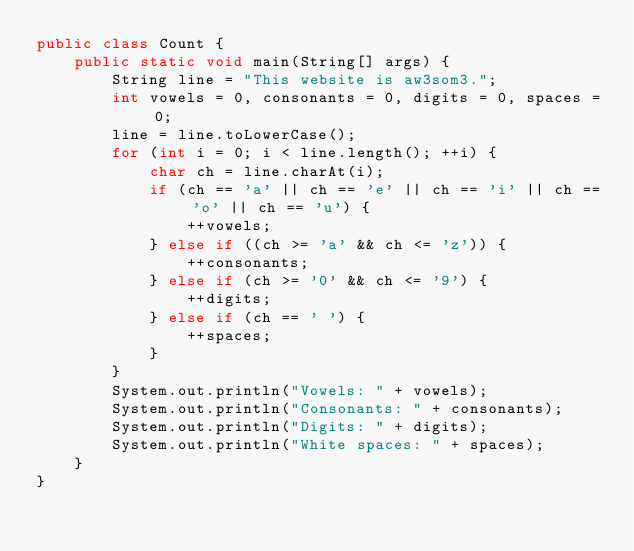Convert code to text. <code><loc_0><loc_0><loc_500><loc_500><_Java_>public class Count {
    public static void main(String[] args) {
        String line = "This website is aw3som3.";
        int vowels = 0, consonants = 0, digits = 0, spaces = 0;
        line = line.toLowerCase();
        for (int i = 0; i < line.length(); ++i) {
            char ch = line.charAt(i);
            if (ch == 'a' || ch == 'e' || ch == 'i' || ch == 'o' || ch == 'u') {
                ++vowels;
            } else if ((ch >= 'a' && ch <= 'z')) {
                ++consonants;
            } else if (ch >= '0' && ch <= '9') {
                ++digits;
            } else if (ch == ' ') {
                ++spaces;
            }
        }
        System.out.println("Vowels: " + vowels);
        System.out.println("Consonants: " + consonants);
        System.out.println("Digits: " + digits);
        System.out.println("White spaces: " + spaces);
    }
}</code> 